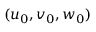Convert formula to latex. <formula><loc_0><loc_0><loc_500><loc_500>( u _ { 0 } , v _ { 0 } , w _ { 0 } )</formula> 